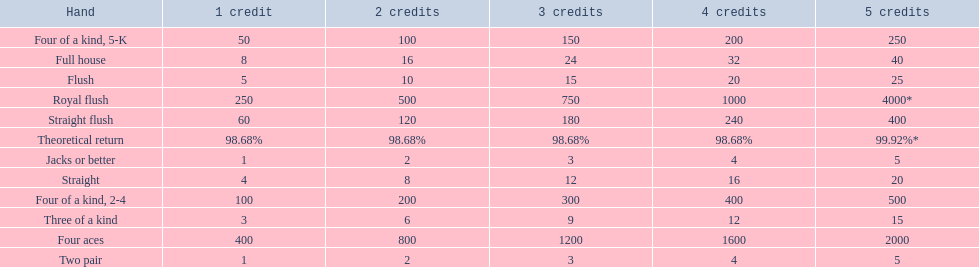What are the hands in super aces? Royal flush, Straight flush, Four aces, Four of a kind, 2-4, Four of a kind, 5-K, Full house, Flush, Straight, Three of a kind, Two pair, Jacks or better. What hand gives the highest credits? Royal flush. 